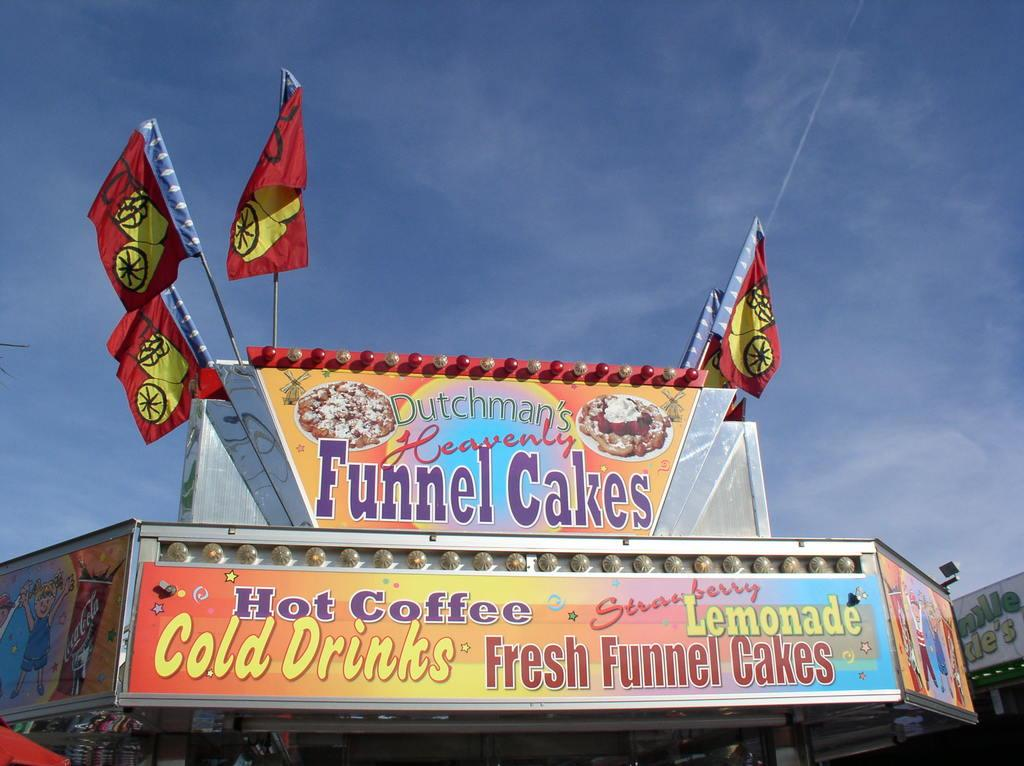What objects are present in the image that have multiple colors? There are two multi-colored boards in the image. What colors are the flags in the image? The flags in the image are red and yellow. What can be seen in the background of the image? The sky is visible in the background of the image. What colors are present in the sky in the image? The sky in the image is blue and white in color. What shape does the crook take in the image? There is no crook present in the image. Can you describe the texture of the shape in the image? The image does not depict a shape with a specific texture. 